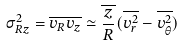<formula> <loc_0><loc_0><loc_500><loc_500>\sigma ^ { 2 } _ { R z } = \overline { v _ { R } v _ { z } } \simeq \overline { \frac { z } { R } } ( \overline { v _ { r } ^ { 2 } } - \overline { v _ { \theta } ^ { 2 } } )</formula> 